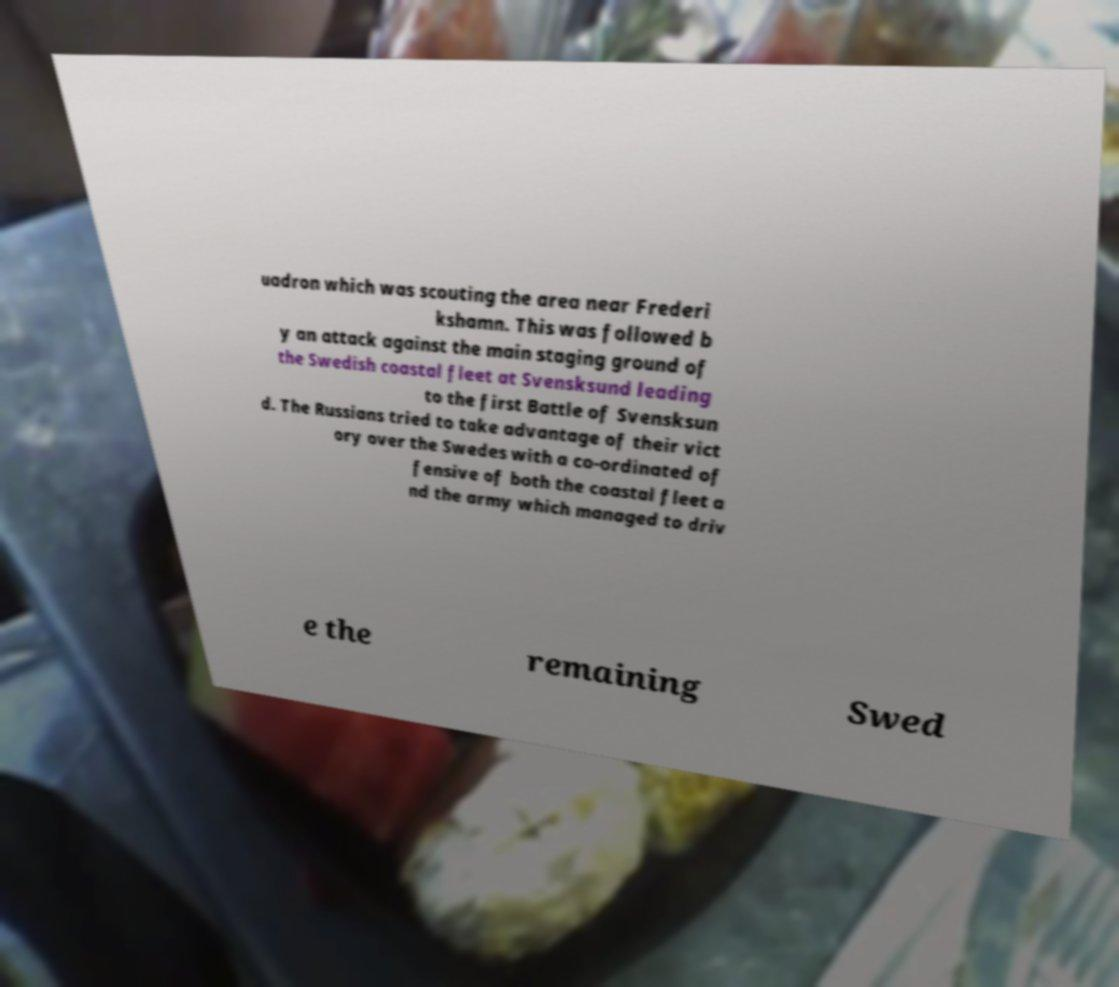Could you extract and type out the text from this image? uadron which was scouting the area near Frederi kshamn. This was followed b y an attack against the main staging ground of the Swedish coastal fleet at Svensksund leading to the first Battle of Svensksun d. The Russians tried to take advantage of their vict ory over the Swedes with a co-ordinated of fensive of both the coastal fleet a nd the army which managed to driv e the remaining Swed 